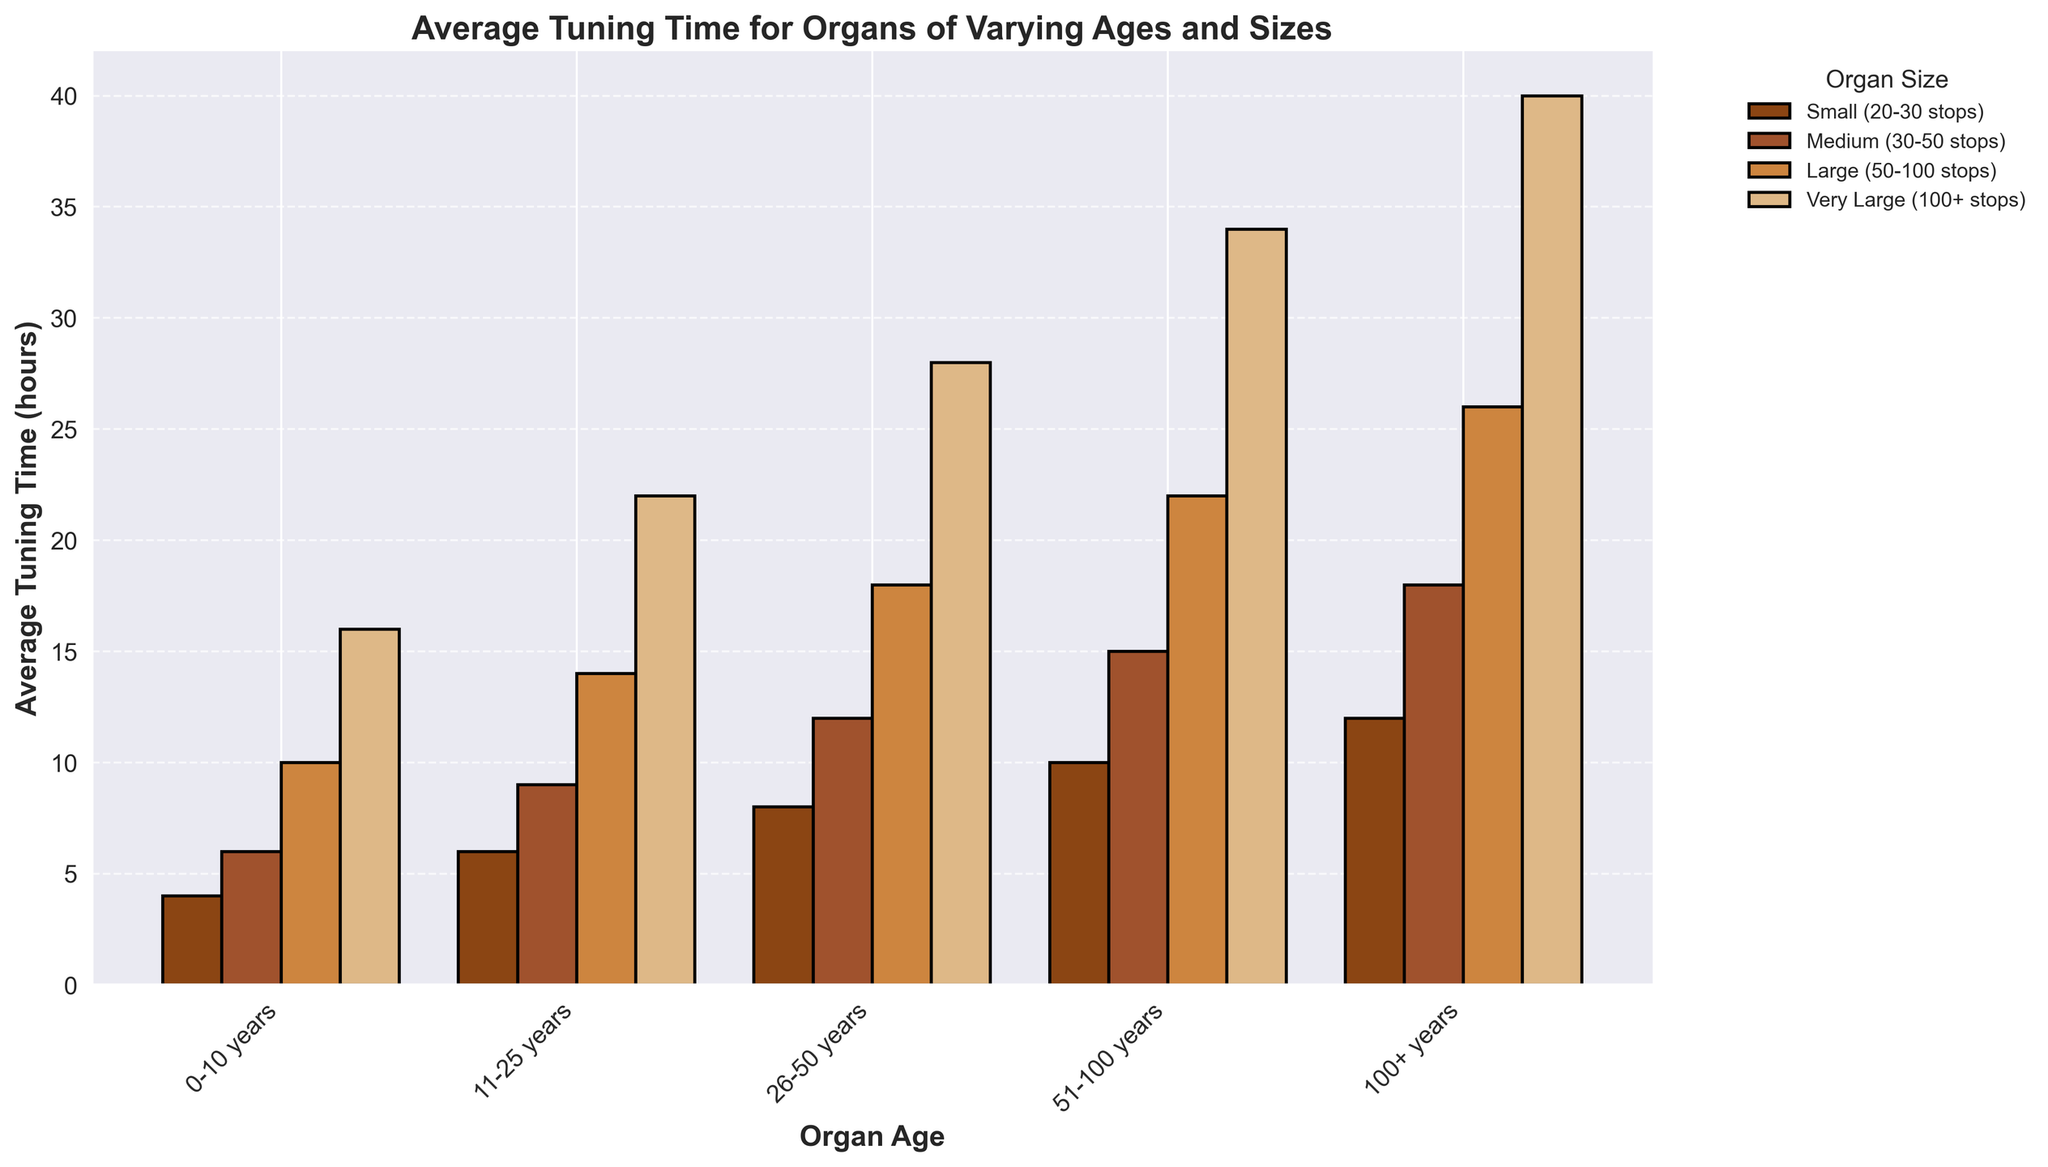Which organ size requires the least average tuning time for organs aged 0-10 years? Look at the bars for the age group 0-10 years and identify the smallest bar. The smallest bar corresponds to small organs (20-30 stops) with 4 hours.
Answer: Small (20-30 stops) What is the difference in average tuning time between very large and small organs for the 51-100 years age group? Identify the heights of the bars for very large organs (100+ stops) and small organs (20-30 stops) for ages 51-100. The difference is 34 hours - 10 hours.
Answer: 24 hours Which age group shows the highest increase in average tuning time for very large organs (100+ stops) compared to the previous age group? Compare the increases in tuning time for very large organs between adjacent age groups: (16 to 22), (22 to 28), (28 to 34), and (34 to 40). The largest increase is from ages 51-100 to 100+ (34 to 40 hours).
Answer: 100+ years What's the average tuning time for medium-sized organs across all age groups? Add the average tuning times of medium organs (6+9+12+15+18) and divide by the number of age groups (5). That's (6+9+12+15+18) = 60; 60/5 = 12.
Answer: 12 hours Which organ size shows the steepest increase in average tuning time from 0-10 years to 100+ years? Compare the increases in tuning time for each organ size: Small (12-4), Medium (18-6), Large (26-10), Very Large (40-16). The steepest increase is for very large organs with (40-16) = 24 hours.
Answer: Very Large (100+ stops) What is the difference in average tuning time between large-sized and medium-sized organs for the age group 26-50 years? Identify the heights of the bars for 26-50 years age group: Large (50-100 stops), 18 hours; Medium (30-50 stops), 12 hours. Their difference is 18 - 12.
Answer: 6 hours Compare the average tuning times for medium organs between the oldest (100+ years) and youngest (0-10 years) age groups. Identify the heights of the bars for medium organs: 18 hours for 100+ years, and 6 hours for 0-10 years. Compare these values, 18 is larger than 6.
Answer: Older organs (18 hours) take longer Which age group has the smallest average tuning time for medium-sized organs (30-50 stops)? Identify the bar with the lowest height for medium organs across all age groups. The smallest bar corresponds to the 0-10 years group with 6 hours.
Answer: 0-10 years 